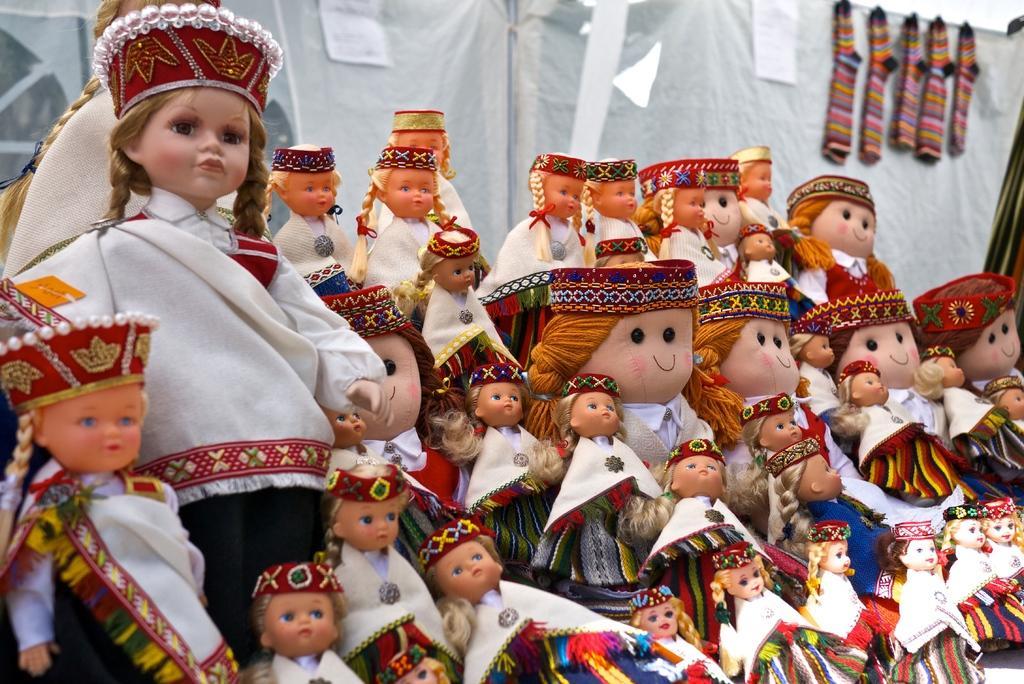Can you describe this image briefly? This image consists of many dolls which are beautifully dressed. In the background, there is a white cloth. 